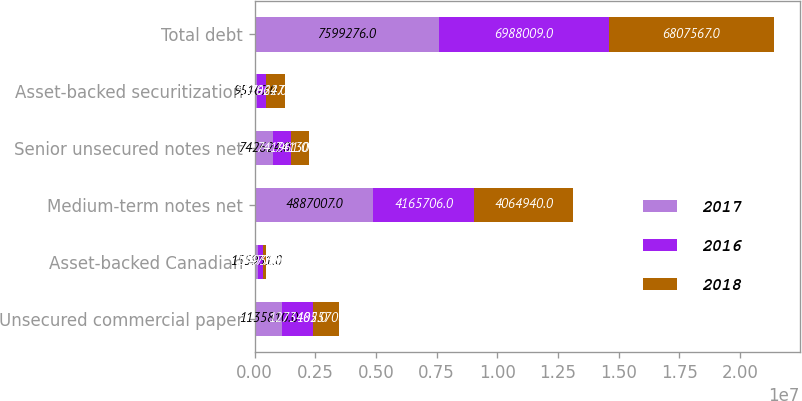<chart> <loc_0><loc_0><loc_500><loc_500><stacked_bar_chart><ecel><fcel>Unsecured commercial paper<fcel>Asset-backed Canadian<fcel>Medium-term notes net<fcel>Senior unsecured notes net<fcel>Asset-backed securitization<fcel>Total debt<nl><fcel>2017<fcel>1.13581e+06<fcel>155951<fcel>4.88701e+06<fcel>742624<fcel>95167<fcel>7.59928e+06<nl><fcel>2016<fcel>1.27348e+06<fcel>174779<fcel>4.16571e+06<fcel>741961<fcel>352624<fcel>6.98801e+06<nl><fcel>2018<fcel>1.05571e+06<fcel>149338<fcel>4.06494e+06<fcel>741306<fcel>796275<fcel>6.80757e+06<nl></chart> 